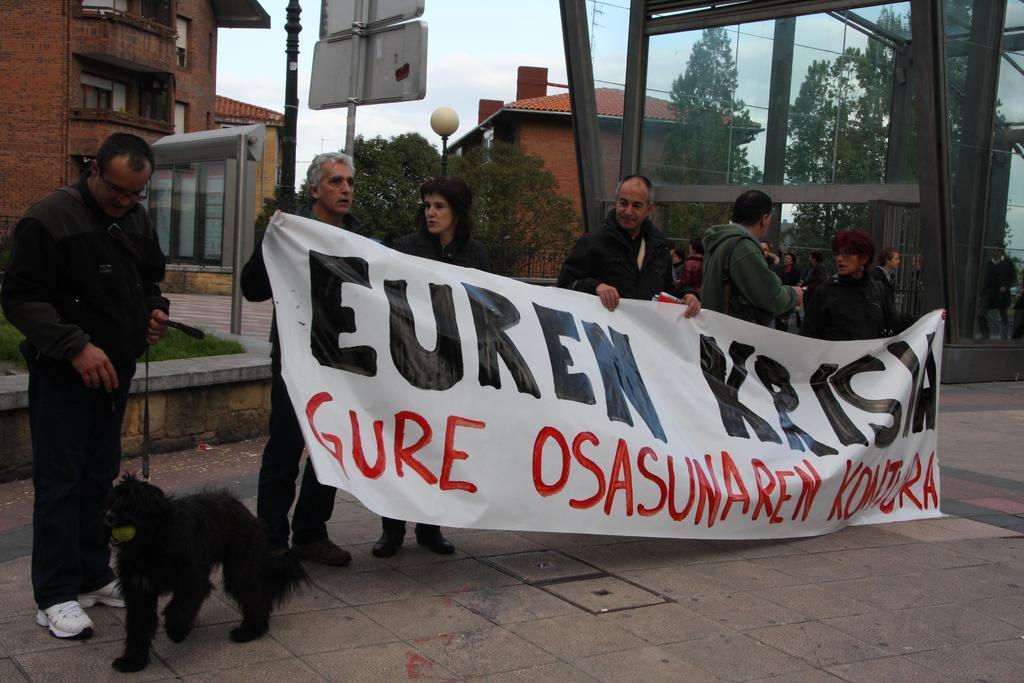Please provide a concise description of this image. In the picture we can find some people are standing and holding a banner and one man is holding a dog he is wearing a white shoe. In the background we can find some trees, houses, sky,boards, poles and light. 